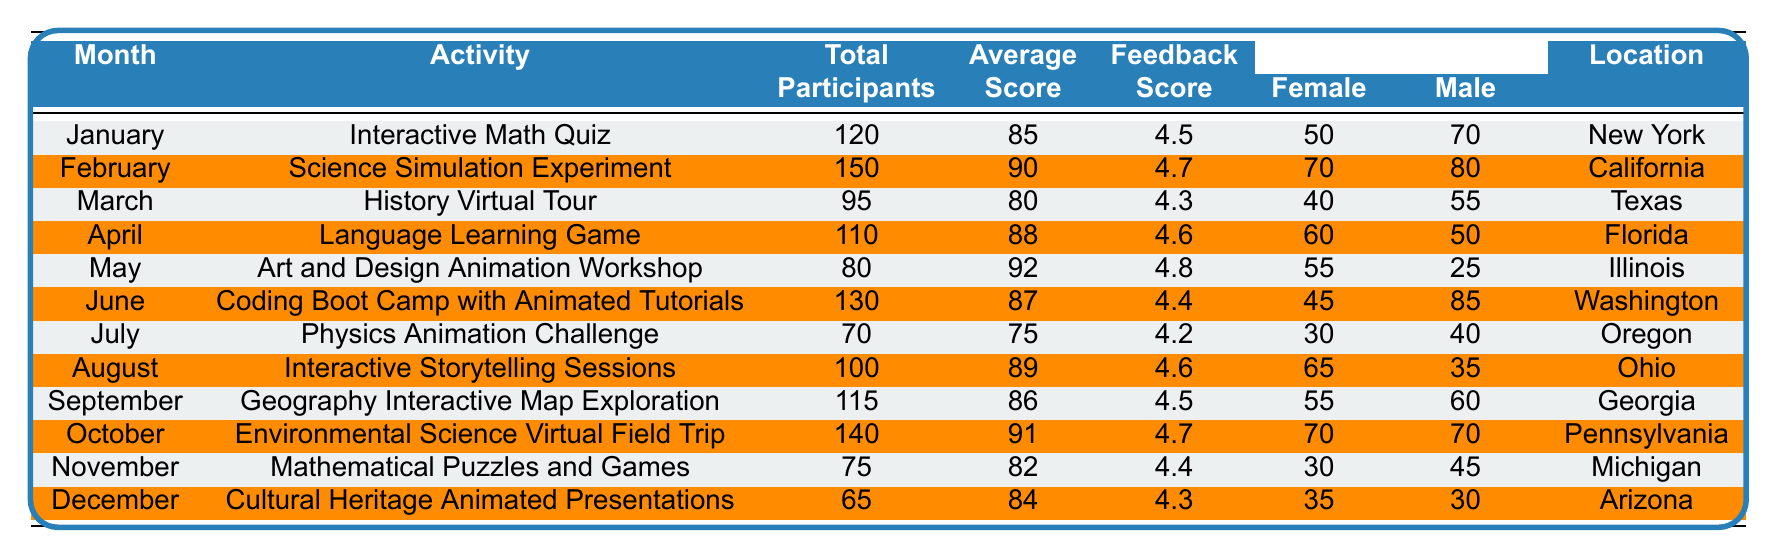What was the total number of participants in February? According to the table, the total number of participants for the "Science Simulation Experiment" in February is explicitly listed as 150.
Answer: 150 Which activity had the highest average score? The "Art and Design Animation Workshop" in May had the highest average score of 92, as seen in the corresponding row of the table.
Answer: Art and Design Animation Workshop How many more male participants than female participants were there in March? In March, there were 55 male participants and 40 female participants. The difference is calculated as 55 - 40 = 15.
Answer: 15 What was the average feedback score for the activities in the first half of the year (January to June)? The feedback scores for January (4.5), February (4.7), March (4.3), April (4.6), May (4.8), and June (4.4) sum up to 28.5, and there are 6 months, so the average is 28.5 / 6 ≈ 4.75.
Answer: 4.75 Was the total number of participants in December greater than the total for November? The table shows that December had 65 participants and November had 75 participants. Since 65 is not greater than 75, the answer is no.
Answer: No What is the total number of female participants across all activities? To find the total female participants, we add the female counts from each month: 50 + 70 + 40 + 60 + 55 + 45 + 30 + 65 + 55 + 70 + 30 + 35 =  630.
Answer: 630 Which location had the least participation in interactive activities? The table shows that the activity with the least participation was the "Cultural Heritage Animated Presentations" in December with 65 participants, indicating Arizona had the least participation.
Answer: Arizona What was the average number of participants for the interactive activities listed? The total number of participants across all activities is 120 + 150 + 95 + 110 + 80 + 130 + 70 + 100 + 115 + 140 + 75 + 65 = 1,195. There are 12 activities, so the average is 1,195 / 12 ≈ 99.58.
Answer: 99.58 What fraction of the total participants in June were female? In June, there were 130 total participants, with 45 being female. The fraction is 45/130, which simplifies to approximately 0.346 or 34.6%.
Answer: 34.6% Is the feedback score for the "Language Learning Game" higher than the average feedback score for all activities? The feedback score for the "Language Learning Game" is 4.6. The average feedback score across all activities is calculated to be 4.55. Since 4.6 is indeed higher, the answer is yes.
Answer: Yes 